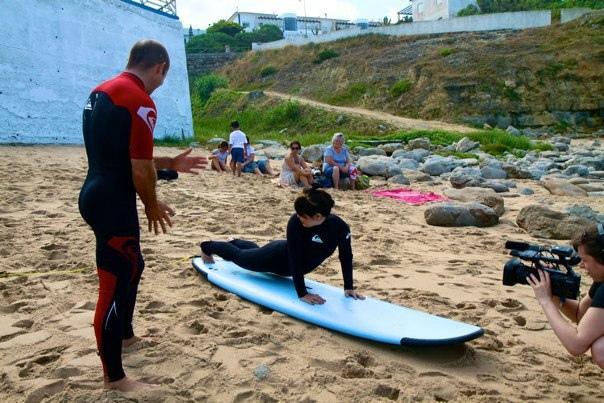Is this board in the water?
Give a very brief answer. No. What is the color of the surfboard?
Concise answer only. Blue. What is the man in the red and black suit doing?
Short answer required. Teaching. 